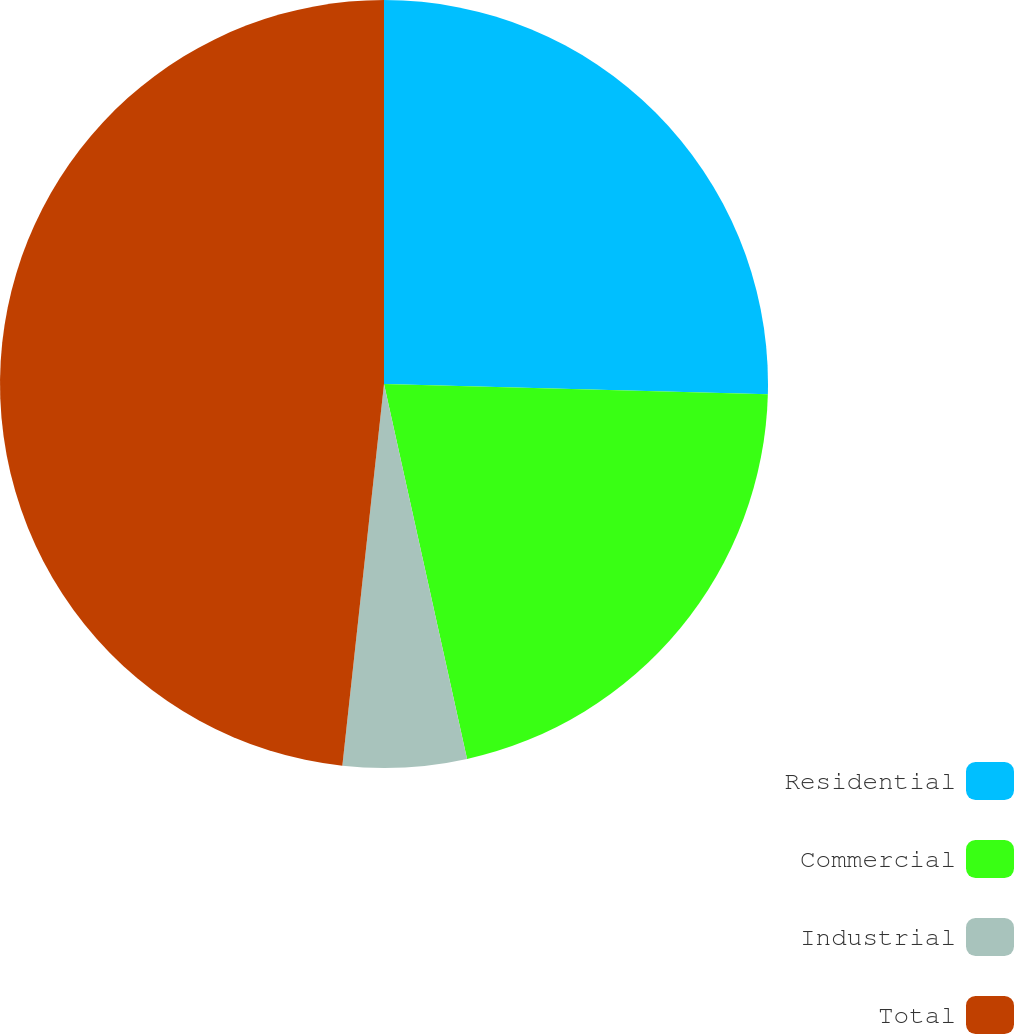Convert chart. <chart><loc_0><loc_0><loc_500><loc_500><pie_chart><fcel>Residential<fcel>Commercial<fcel>Industrial<fcel>Total<nl><fcel>25.42%<fcel>21.11%<fcel>5.2%<fcel>48.27%<nl></chart> 